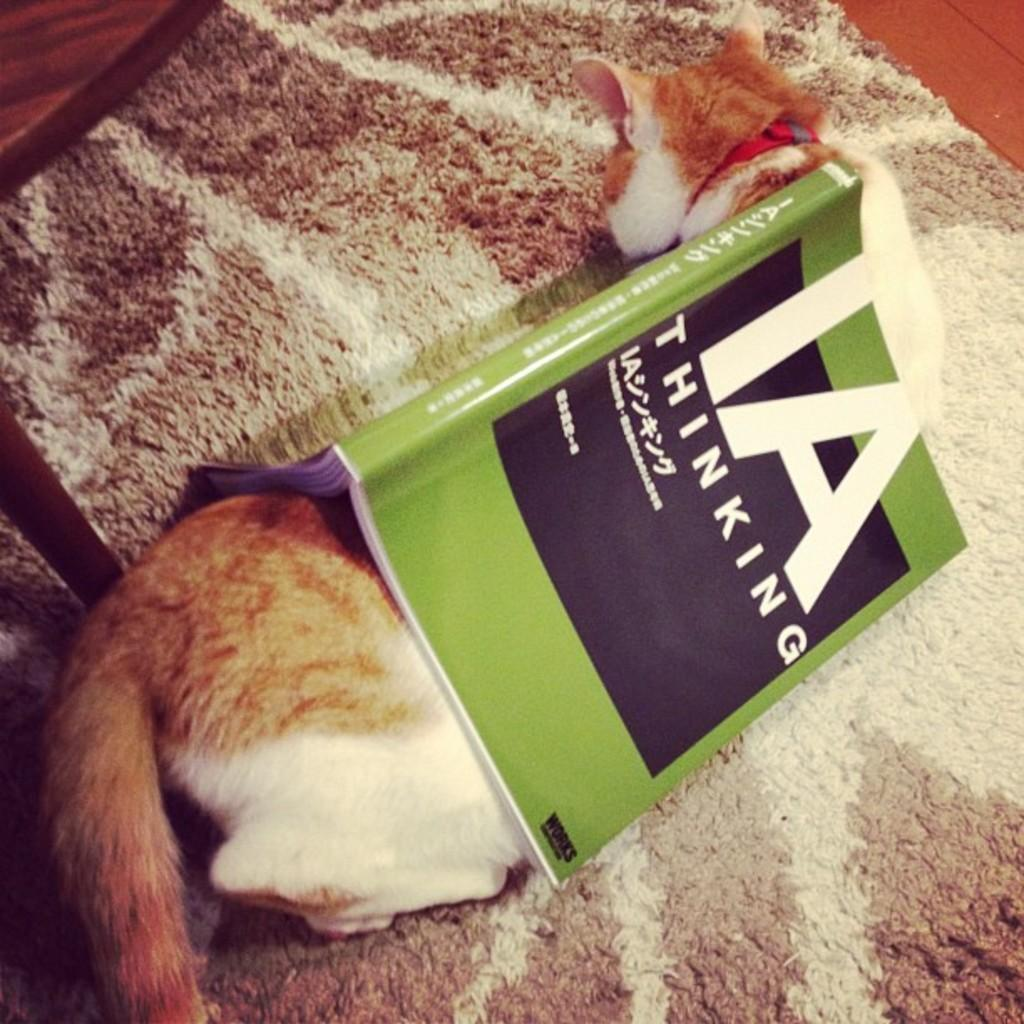What type of animal is in the image? There is a cat in the image. Where is the cat located? The cat is on a mat. Is there anything on top of the cat? Yes, there is a book on top of the cat. How many pies are being served on the table in the image? There is no table or pies present in the image; it features a cat on a mat with a book on top of it. What fact can be learned about the cat's diet from the image? The image does not provide any information about the cat's diet. 